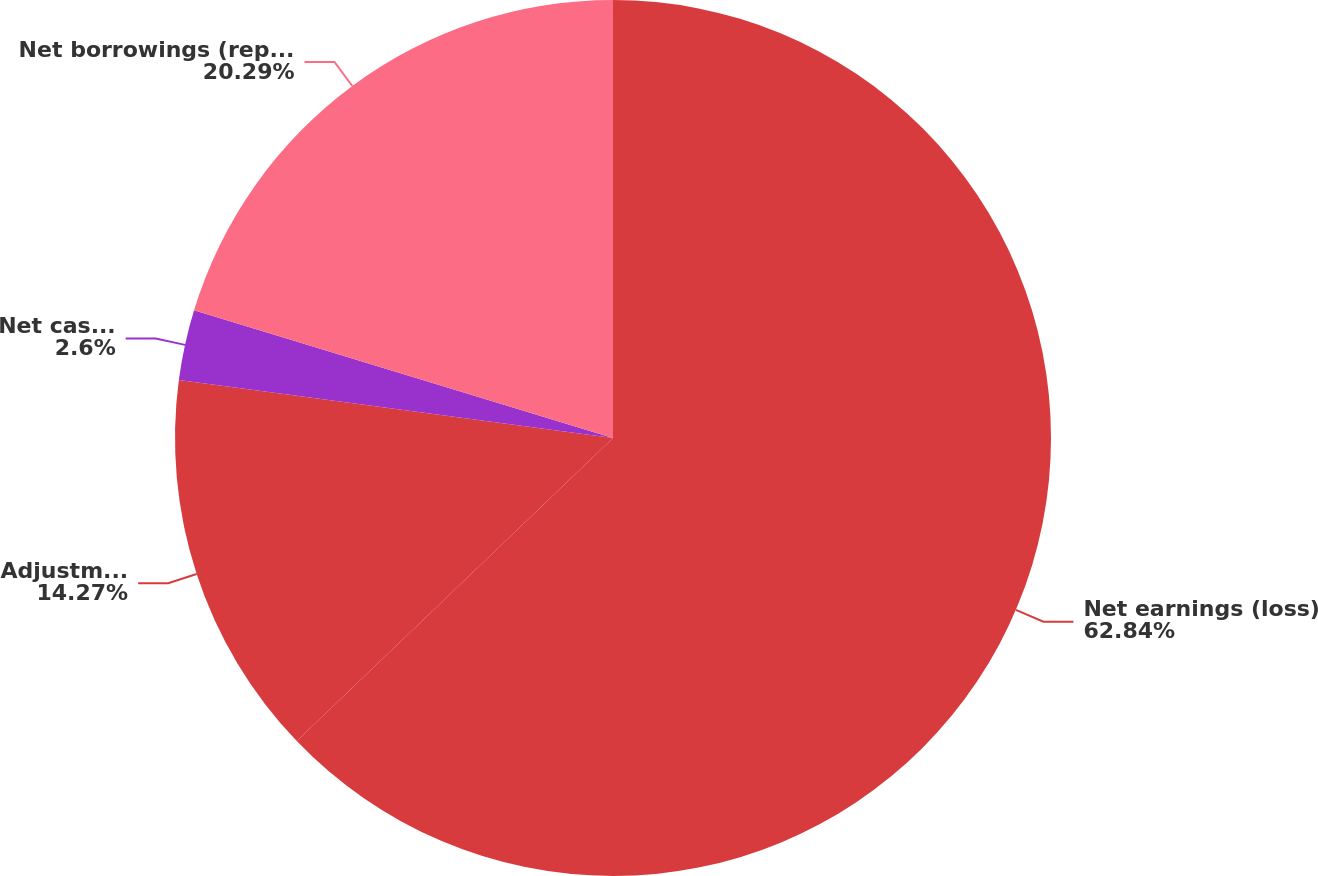Convert chart. <chart><loc_0><loc_0><loc_500><loc_500><pie_chart><fcel>Net earnings (loss)<fcel>Adjustments to reconcile net<fcel>Net cash provided by (used in)<fcel>Net borrowings (repayments)<nl><fcel>62.84%<fcel>14.27%<fcel>2.6%<fcel>20.29%<nl></chart> 